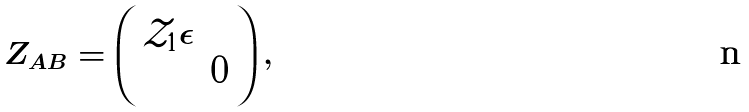<formula> <loc_0><loc_0><loc_500><loc_500>Z _ { A B } = \left ( \begin{array} { c c } \mathcal { Z } _ { 1 } \epsilon & \\ & 0 \end{array} \right ) ,</formula> 